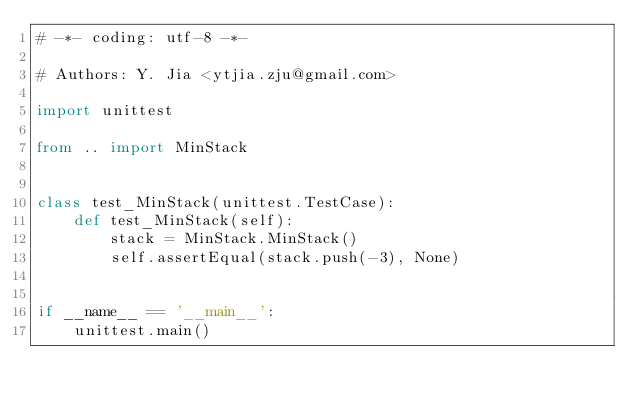Convert code to text. <code><loc_0><loc_0><loc_500><loc_500><_Python_># -*- coding: utf-8 -*-

# Authors: Y. Jia <ytjia.zju@gmail.com>

import unittest

from .. import MinStack


class test_MinStack(unittest.TestCase):
    def test_MinStack(self):
        stack = MinStack.MinStack()
        self.assertEqual(stack.push(-3), None)


if __name__ == '__main__':
    unittest.main()
</code> 